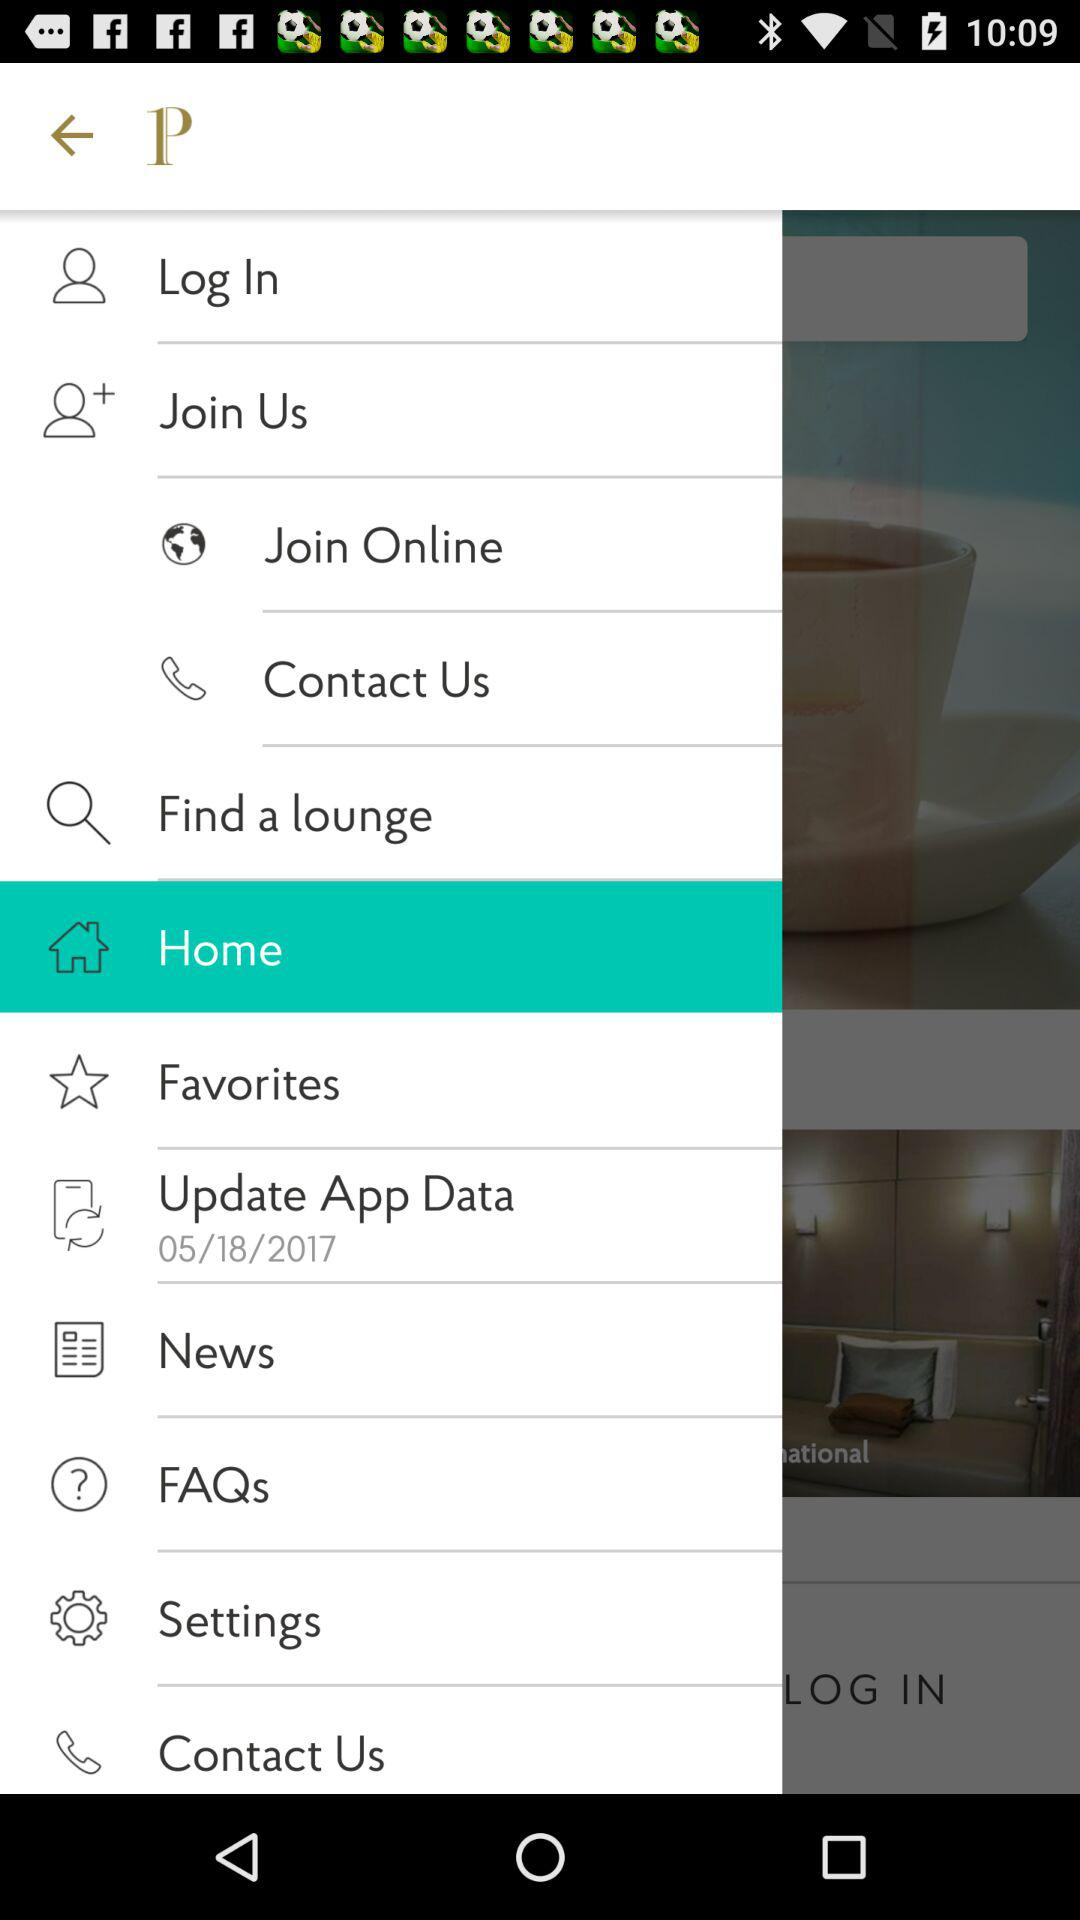What is the application name? The application name is "P". 